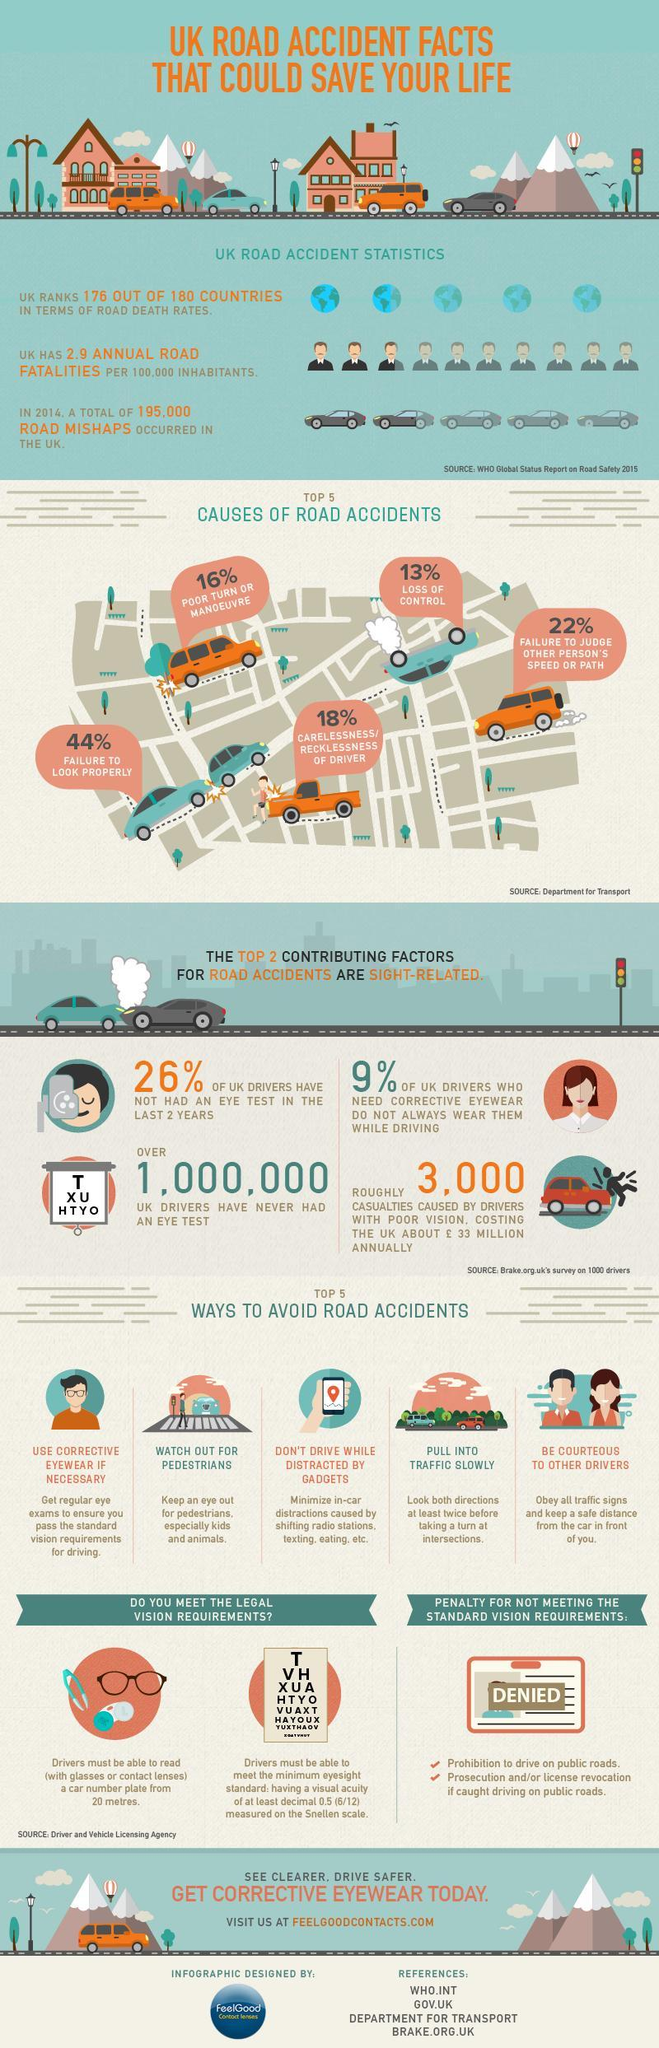What is the top most cause of road accidents in UK ?
Answer the question with a short phrase. Failure to look properly Which are the top two contributing factors for road accidents, that are sight related ? Failure to look properly, failure to judge other person's speed or path What percent of UK drivers have had their eyes tested in the last 2 years ? 74% What are the two kinds of pedestrians, the driver is expected to be very careful about ? Kids, animals What are the three common distractions inside a  car, while driving ? Shifting radio stations, texting, eating What percent of accidents were caused by reckless driving ? 18% What percent of the drivers do not wear their  prescription glasses ? 9% By what percent is accidents caused due to a poor turn more than the accidents caused due to loss of control ? 3% 